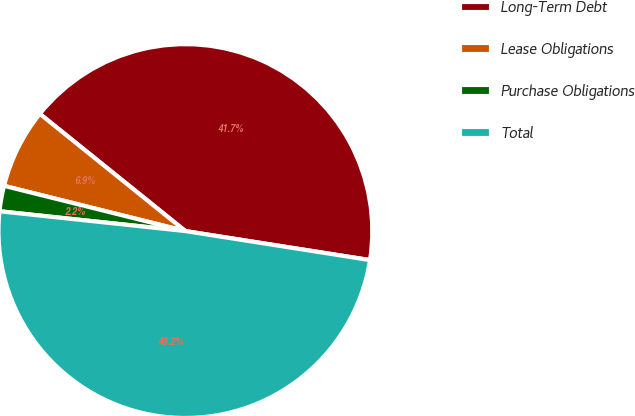Convert chart. <chart><loc_0><loc_0><loc_500><loc_500><pie_chart><fcel>Long-Term Debt<fcel>Lease Obligations<fcel>Purchase Obligations<fcel>Total<nl><fcel>41.69%<fcel>6.9%<fcel>2.2%<fcel>49.21%<nl></chart> 